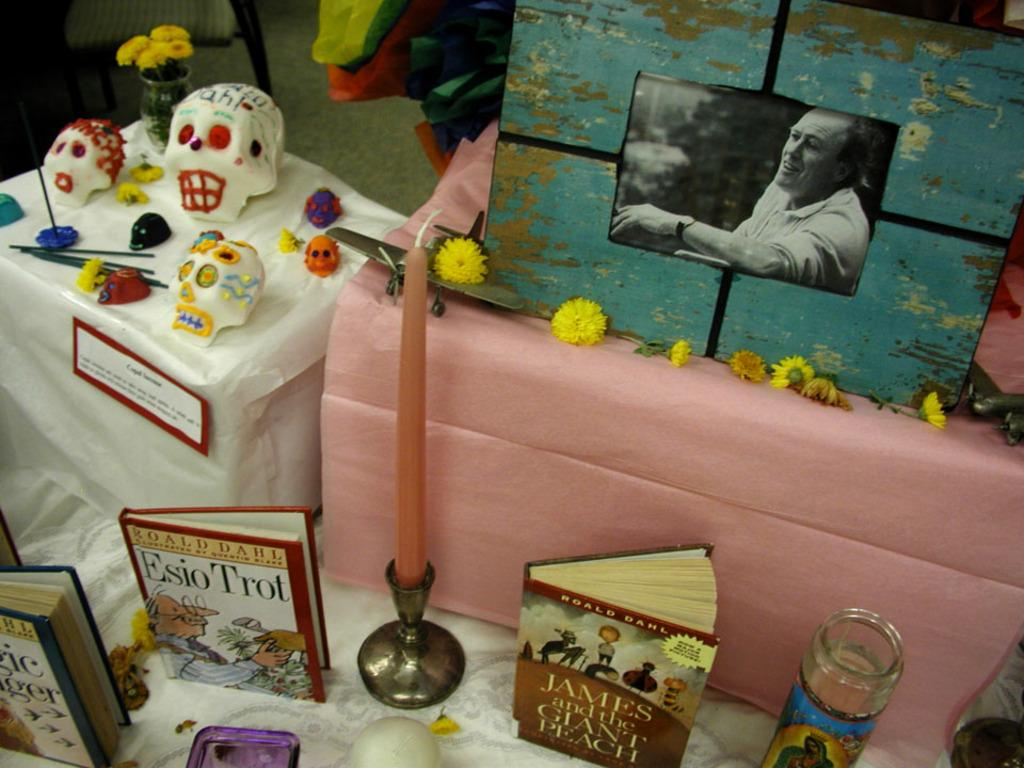What object can be seen in the image that is typically used for reading? There is a book in the image that is typically used for reading. What object in the image is used for providing light? There is a candle in the image, and it is placed in a candle holder. What is the purpose of the bottle in the image? The purpose of the bottle in the image is not specified, but it could be used for holding liquid or as a decorative item. What type of decorative items are present in the image? There are toy skulls and flowers in the image. What object in the image is used for displaying photographs? There is a picture frame in the image, which is used for displaying photographs. What object in the image is used for holding flowers? There is a flower vase with flowers in the image. What type of wire is used to hold the flowers in the image? There is no wire present in the image; the flowers are held in a vase. How does the dust affect the visibility of the objects in the image? There is no mention of dust in the image, so it cannot be determined how it would affect the visibility of the objects. 